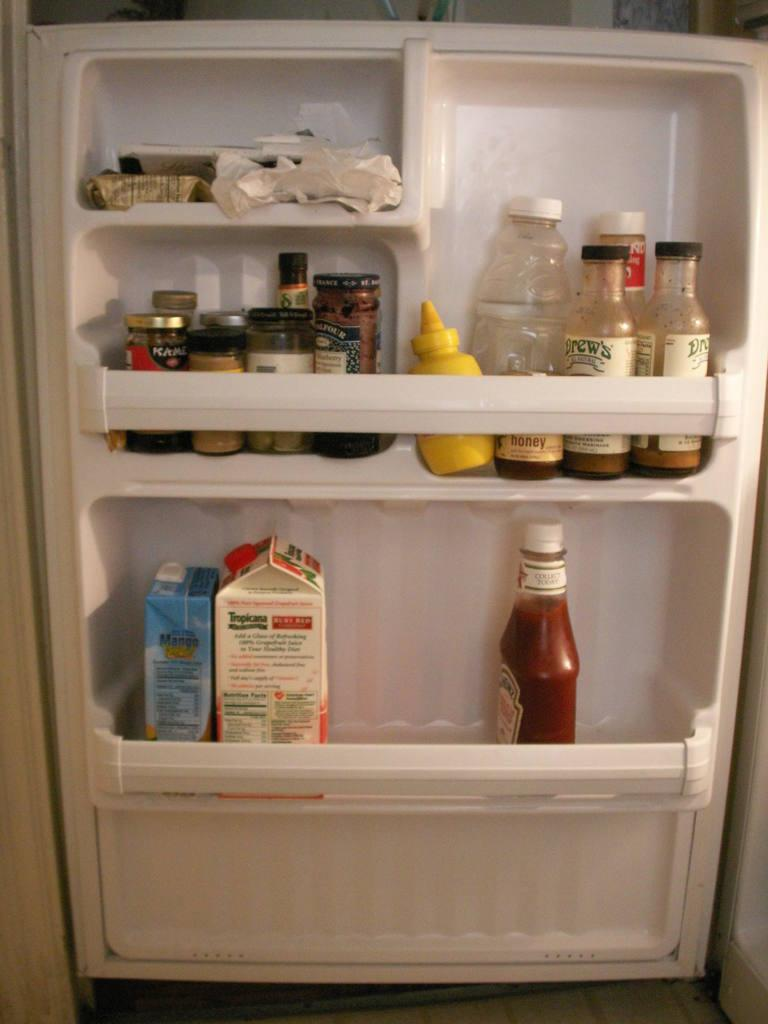What types of containers are visible in the image? There are bottles and jars in the image. Where are these containers located? The containers are located on a refrigerator door in the image. Can you tell me how many horns are attached to the refrigerator door in the image? There are no horns present on the refrigerator door in the image. What type of tin is used to store the items in the jars? The provided facts do not mention any tin being used to store items in the jars. 